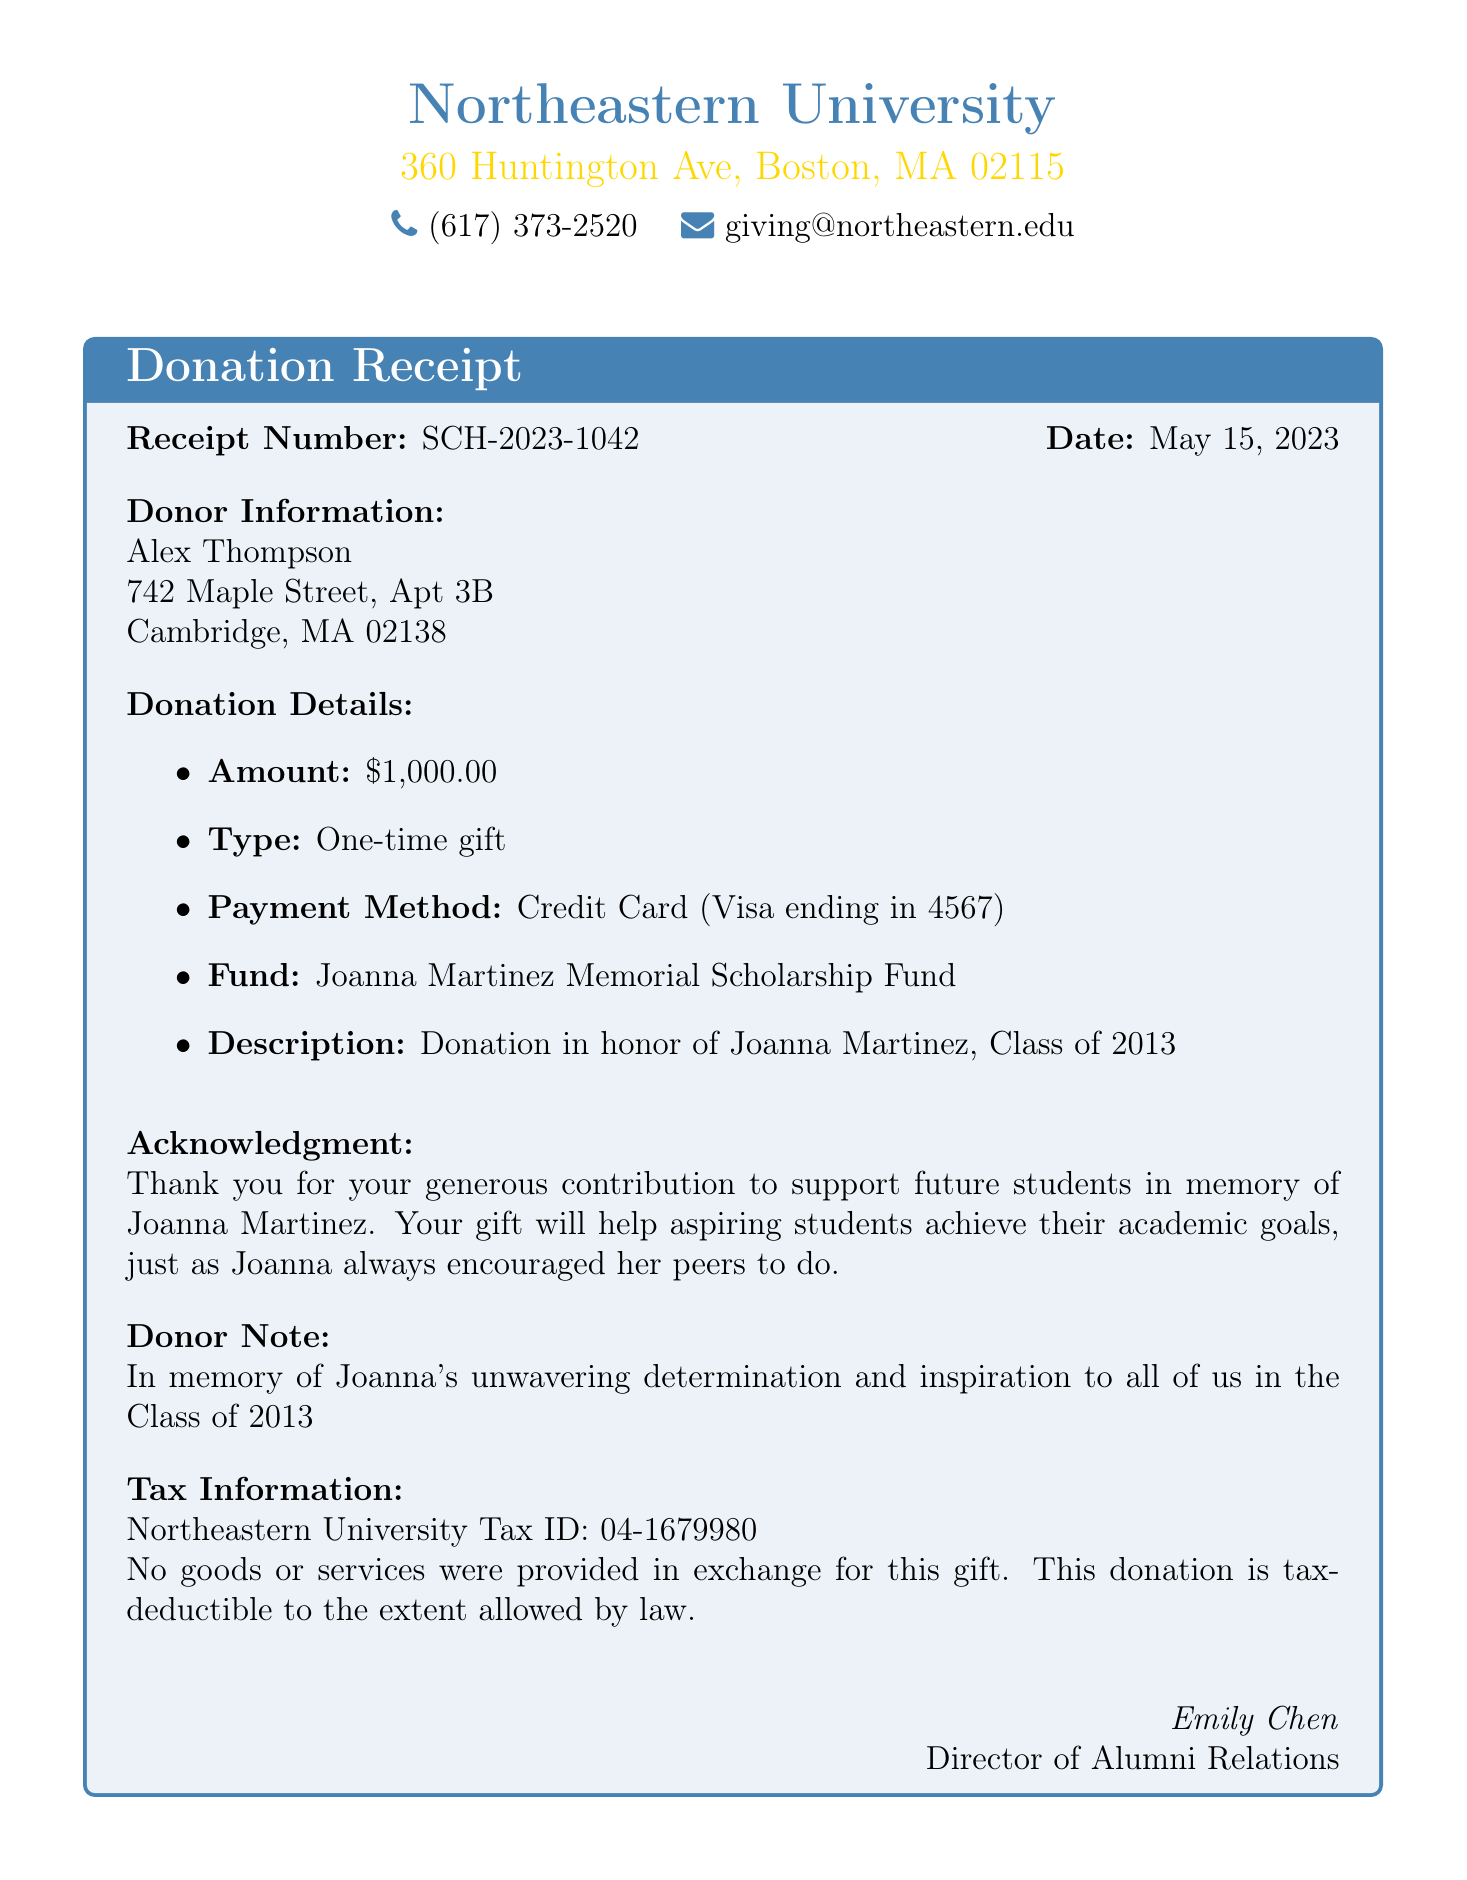What is the receipt number? The receipt number is specifically labeled in the document for reference purposes.
Answer: SCH-2023-1042 Who is the donor? The donor's name is stated clearly at the beginning of the donor information section.
Answer: Alex Thompson What is the donation amount? The donation amount is explicitly mentioned in the donation details of the document.
Answer: $1,000.00 What type of donation was made? The type of donation is described in the donation details section, indicating the nature of the contribution.
Answer: One-time gift What is the name of the scholarship fund? The name of the scholarship fund is highlighted in the donation details, as it acknowledges the purpose of the donation.
Answer: Joanna Martinez Memorial Scholarship Fund Who acknowledged the donation? The acknowledgment section of the document states who expressed gratitude for the donation.
Answer: Emily Chen What is the college name? The name of the college is prominently displayed at the top of the receipt, representing the institution involved.
Answer: Northeastern University What was the reason for the donation? The specific reason for the donation is included in the acknowledgment and donor note sections of the document.
Answer: In memory of Joanna's unwavering determination and inspiration to all of us in the Class of 2013 What payment method was used for the donation? The payment method is clearly indicated in the donation details section of the document.
Answer: Credit Card (Visa ending in 4567) 